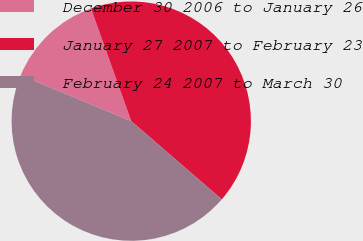<chart> <loc_0><loc_0><loc_500><loc_500><pie_chart><fcel>December 30 2006 to January 26<fcel>January 27 2007 to February 23<fcel>February 24 2007 to March 30<nl><fcel>13.27%<fcel>41.8%<fcel>44.92%<nl></chart> 